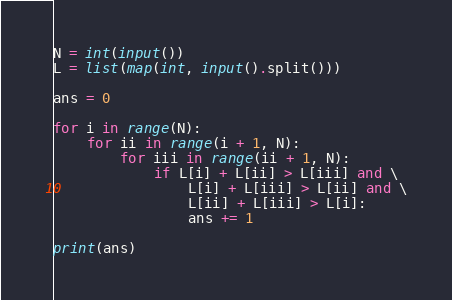Convert code to text. <code><loc_0><loc_0><loc_500><loc_500><_Python_>N = int(input())
L = list(map(int, input().split()))

ans = 0

for i in range(N):
    for ii in range(i + 1, N):
        for iii in range(ii + 1, N):
            if L[i] + L[ii] > L[iii] and \
                L[i] + L[iii] > L[ii] and \
                L[ii] + L[iii] > L[i]:
                ans += 1

print(ans)</code> 